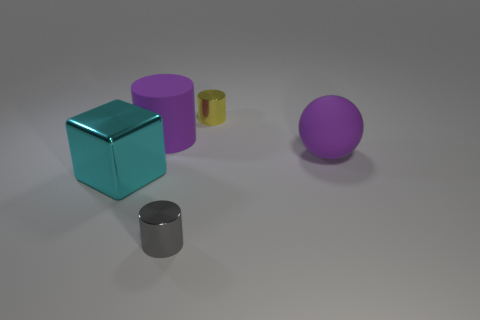Add 1 large cyan things. How many objects exist? 6 Subtract all blocks. How many objects are left? 4 Subtract 0 cyan balls. How many objects are left? 5 Subtract all purple rubber cubes. Subtract all large cylinders. How many objects are left? 4 Add 2 rubber objects. How many rubber objects are left? 4 Add 5 rubber balls. How many rubber balls exist? 6 